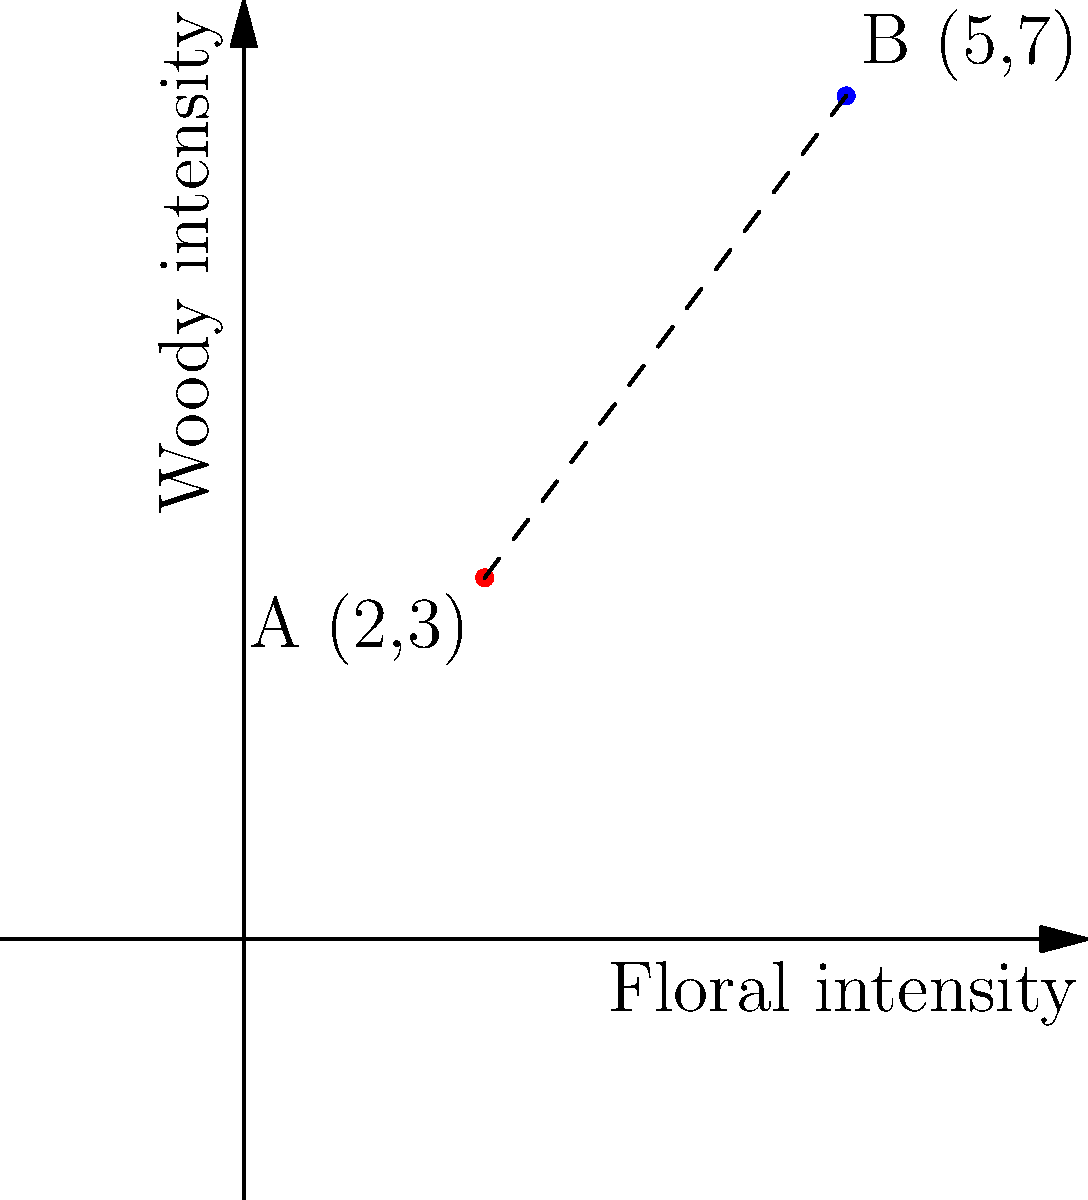In your fragrance intensity coordinate system, point A (2,3) represents a candle with floral and woody notes, while point B (5,7) represents a soap with different intensities of the same scents. Calculate the distance between these two points to determine how different the scent profiles are. To find the distance between two points on a coordinate plane, we use the distance formula, which is derived from the Pythagorean theorem:

$$ d = \sqrt{(x_2 - x_1)^2 + (y_2 - y_1)^2} $$

Where $(x_1, y_1)$ are the coordinates of the first point and $(x_2, y_2)$ are the coordinates of the second point.

Given:
Point A (candle): $(x_1, y_1) = (2, 3)$
Point B (soap): $(x_2, y_2) = (5, 7)$

Let's substitute these values into the formula:

$$ d = \sqrt{(5 - 2)^2 + (7 - 3)^2} $$

Now, let's solve step by step:

1) Simplify the expressions inside the parentheses:
   $$ d = \sqrt{3^2 + 4^2} $$

2) Calculate the squares:
   $$ d = \sqrt{9 + 16} $$

3) Add the numbers under the square root:
   $$ d = \sqrt{25} $$

4) Simplify the square root:
   $$ d = 5 $$

Therefore, the distance between the two scent profiles is 5 units on the fragrance intensity scale.
Answer: 5 units 